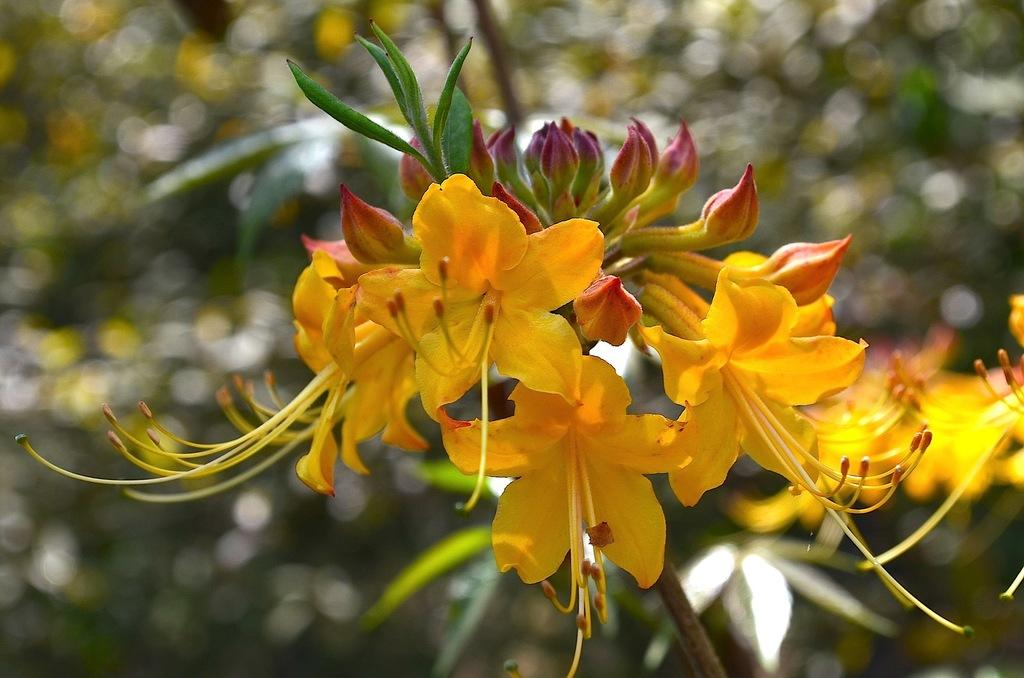What is present in the image? There are flowers in the image. Can you describe the background of the image? The background of the image is blurry. What type of drug is being invented in the image? There is no reference to a drug or invention in the image; it features flowers and a blurry background. 